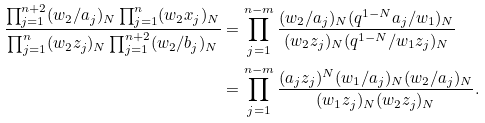Convert formula to latex. <formula><loc_0><loc_0><loc_500><loc_500>\frac { \prod _ { j = 1 } ^ { n + 2 } ( w _ { 2 } / a _ { j } ) _ { N } \prod _ { j = 1 } ^ { n } ( w _ { 2 } x _ { j } ) _ { N } } { \prod _ { j = 1 } ^ { n } ( w _ { 2 } z _ { j } ) _ { N } \prod _ { j = 1 } ^ { n + 2 } ( w _ { 2 } / b _ { j } ) _ { N } } & = \prod _ { j = 1 } ^ { n - m } \frac { ( w _ { 2 } / a _ { j } ) _ { N } ( q ^ { 1 - N } a _ { j } / w _ { 1 } ) _ { N } } { ( w _ { 2 } z _ { j } ) _ { N } ( q ^ { 1 - N } / w _ { 1 } z _ { j } ) _ { N } } \\ & = \prod _ { j = 1 } ^ { n - m } \frac { ( a _ { j } z _ { j } ) ^ { N } ( w _ { 1 } / a _ { j } ) _ { N } ( w _ { 2 } / a _ { j } ) _ { N } } { ( w _ { 1 } z _ { j } ) _ { N } ( w _ { 2 } z _ { j } ) _ { N } } .</formula> 